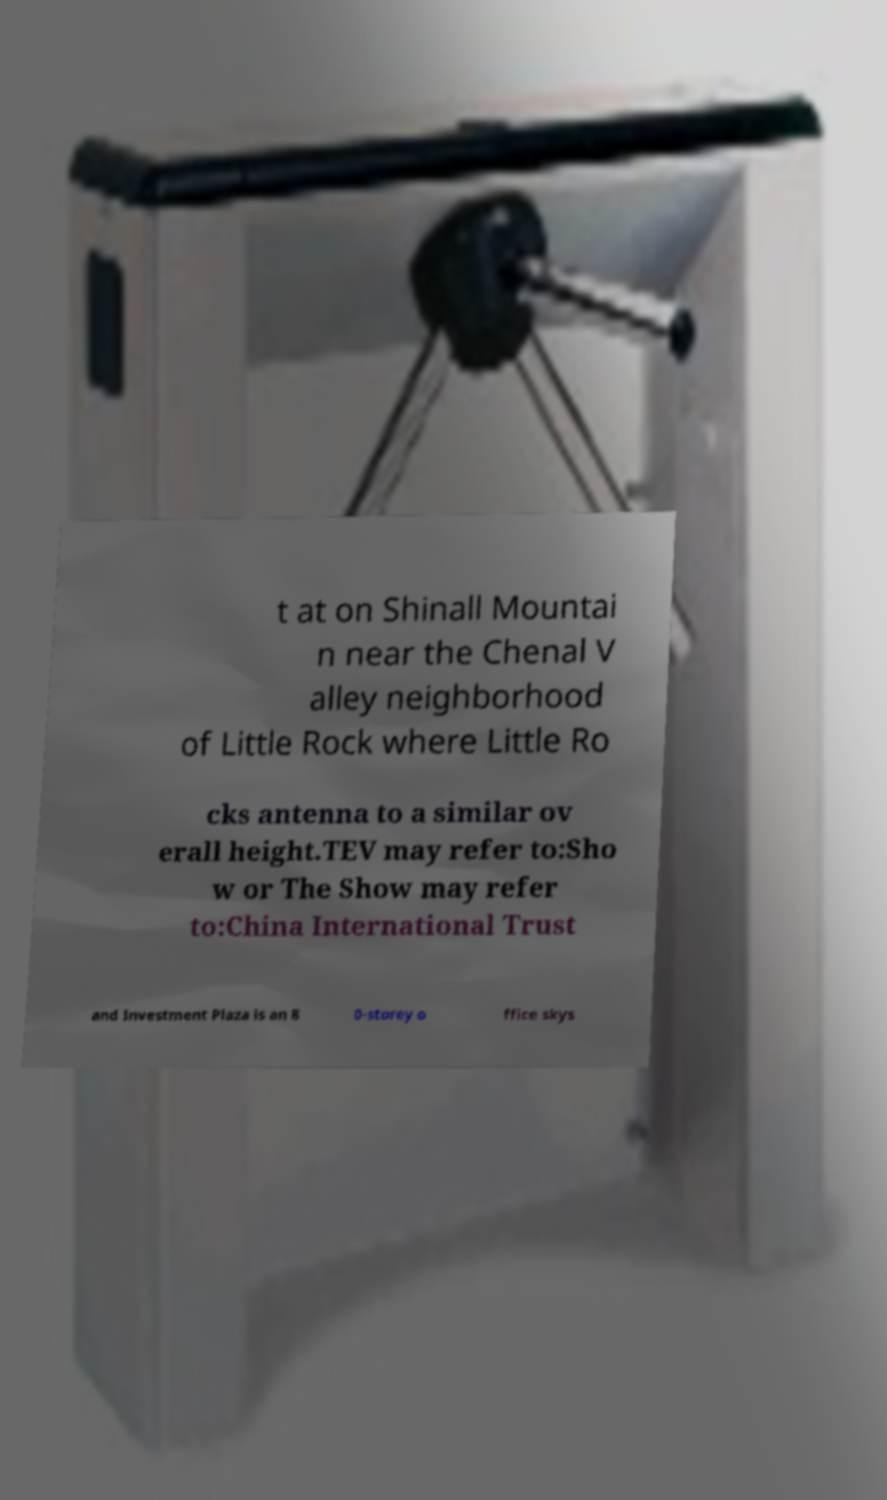Please identify and transcribe the text found in this image. t at on Shinall Mountai n near the Chenal V alley neighborhood of Little Rock where Little Ro cks antenna to a similar ov erall height.TEV may refer to:Sho w or The Show may refer to:China International Trust and Investment Plaza is an 8 0-storey o ffice skys 